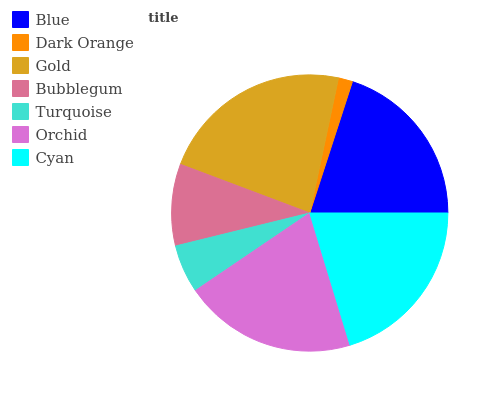Is Dark Orange the minimum?
Answer yes or no. Yes. Is Gold the maximum?
Answer yes or no. Yes. Is Gold the minimum?
Answer yes or no. No. Is Dark Orange the maximum?
Answer yes or no. No. Is Gold greater than Dark Orange?
Answer yes or no. Yes. Is Dark Orange less than Gold?
Answer yes or no. Yes. Is Dark Orange greater than Gold?
Answer yes or no. No. Is Gold less than Dark Orange?
Answer yes or no. No. Is Blue the high median?
Answer yes or no. Yes. Is Blue the low median?
Answer yes or no. Yes. Is Cyan the high median?
Answer yes or no. No. Is Gold the low median?
Answer yes or no. No. 